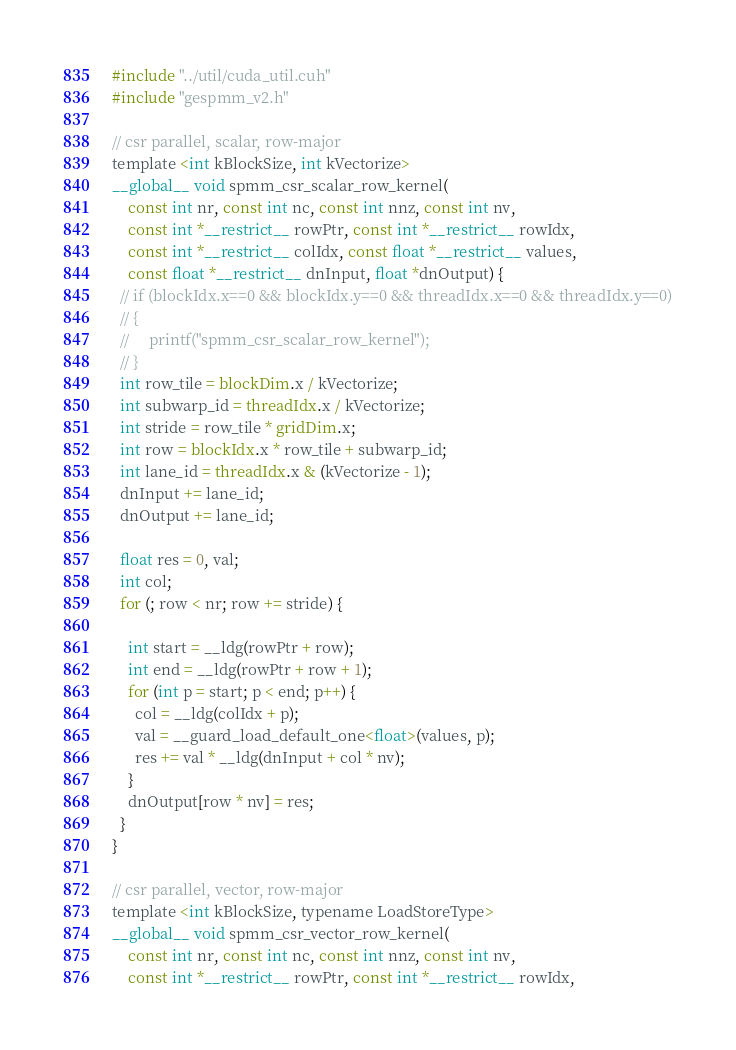<code> <loc_0><loc_0><loc_500><loc_500><_Cuda_>#include "../util/cuda_util.cuh"
#include "gespmm_v2.h"

// csr parallel, scalar, row-major
template <int kBlockSize, int kVectorize>
__global__ void spmm_csr_scalar_row_kernel(
    const int nr, const int nc, const int nnz, const int nv,
    const int *__restrict__ rowPtr, const int *__restrict__ rowIdx,
    const int *__restrict__ colIdx, const float *__restrict__ values,
    const float *__restrict__ dnInput, float *dnOutput) {
  // if (blockIdx.x==0 && blockIdx.y==0 && threadIdx.x==0 && threadIdx.y==0)
  // {
  //     printf("spmm_csr_scalar_row_kernel");
  // }
  int row_tile = blockDim.x / kVectorize;
  int subwarp_id = threadIdx.x / kVectorize;
  int stride = row_tile * gridDim.x;
  int row = blockIdx.x * row_tile + subwarp_id;
  int lane_id = threadIdx.x & (kVectorize - 1);
  dnInput += lane_id;
  dnOutput += lane_id;

  float res = 0, val;
  int col;
  for (; row < nr; row += stride) {

    int start = __ldg(rowPtr + row);
    int end = __ldg(rowPtr + row + 1);
    for (int p = start; p < end; p++) {
      col = __ldg(colIdx + p);
      val = __guard_load_default_one<float>(values, p);
      res += val * __ldg(dnInput + col * nv);
    }
    dnOutput[row * nv] = res;
  }
}

// csr parallel, vector, row-major
template <int kBlockSize, typename LoadStoreType>
__global__ void spmm_csr_vector_row_kernel(
    const int nr, const int nc, const int nnz, const int nv,
    const int *__restrict__ rowPtr, const int *__restrict__ rowIdx,</code> 